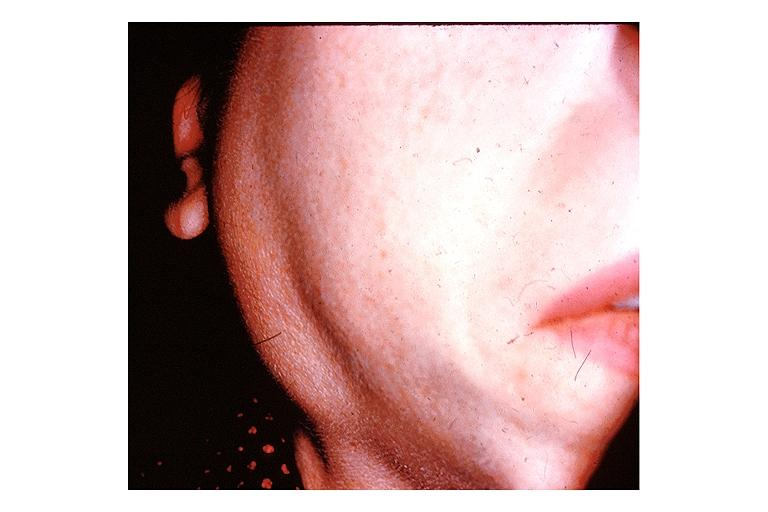does carcinomatous meningitis show sjogrens syndrome?
Answer the question using a single word or phrase. No 